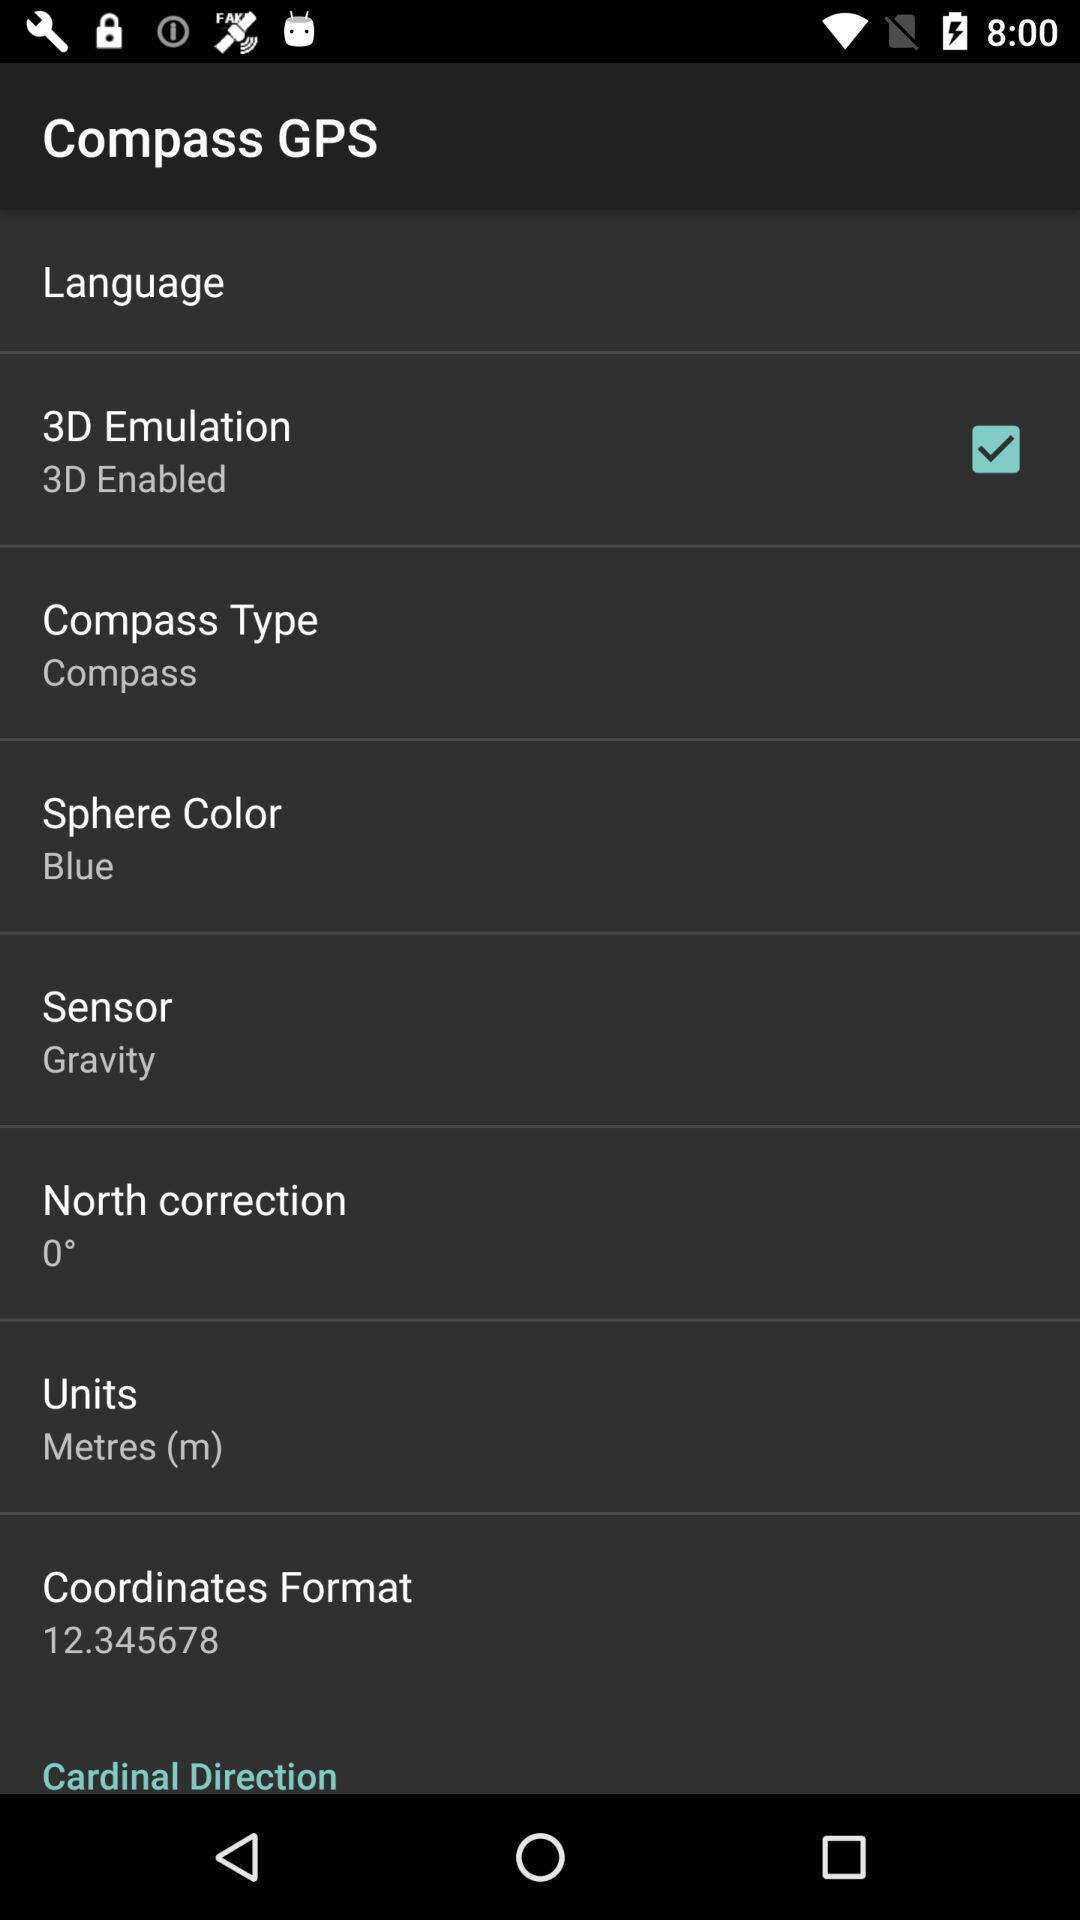What is the longitude? The longitude is -122.450059. 